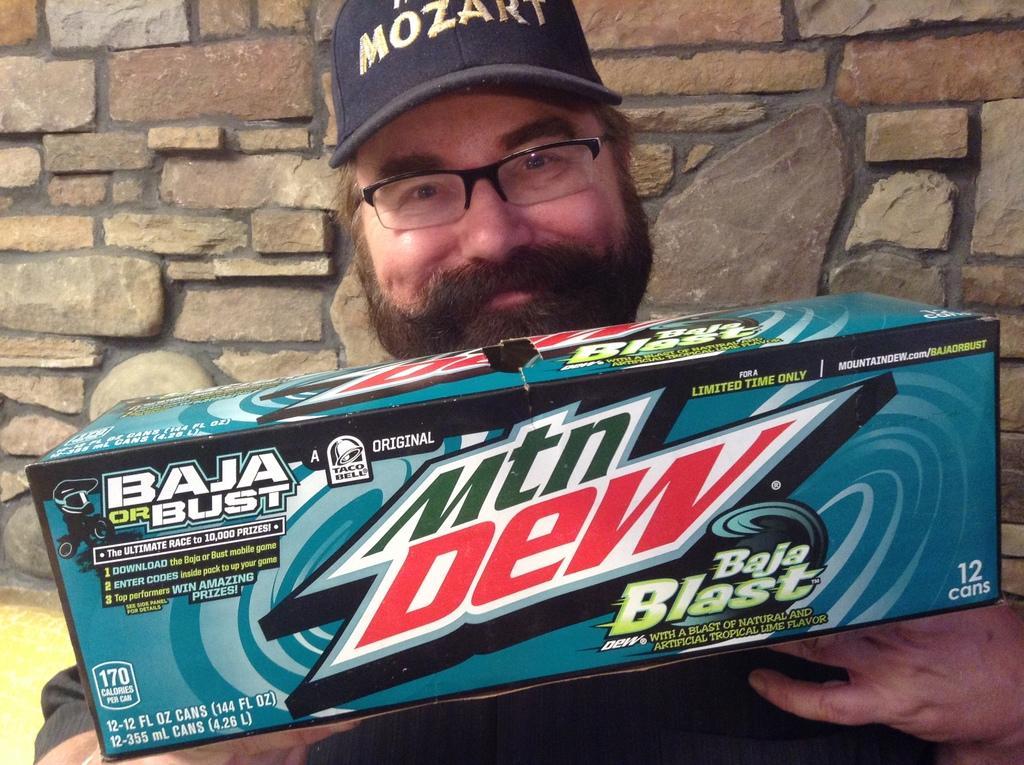Describe this image in one or two sentences. In the image there is a man, he is holding a mountain dew box with his hand and behind the man there is a brick wall. 